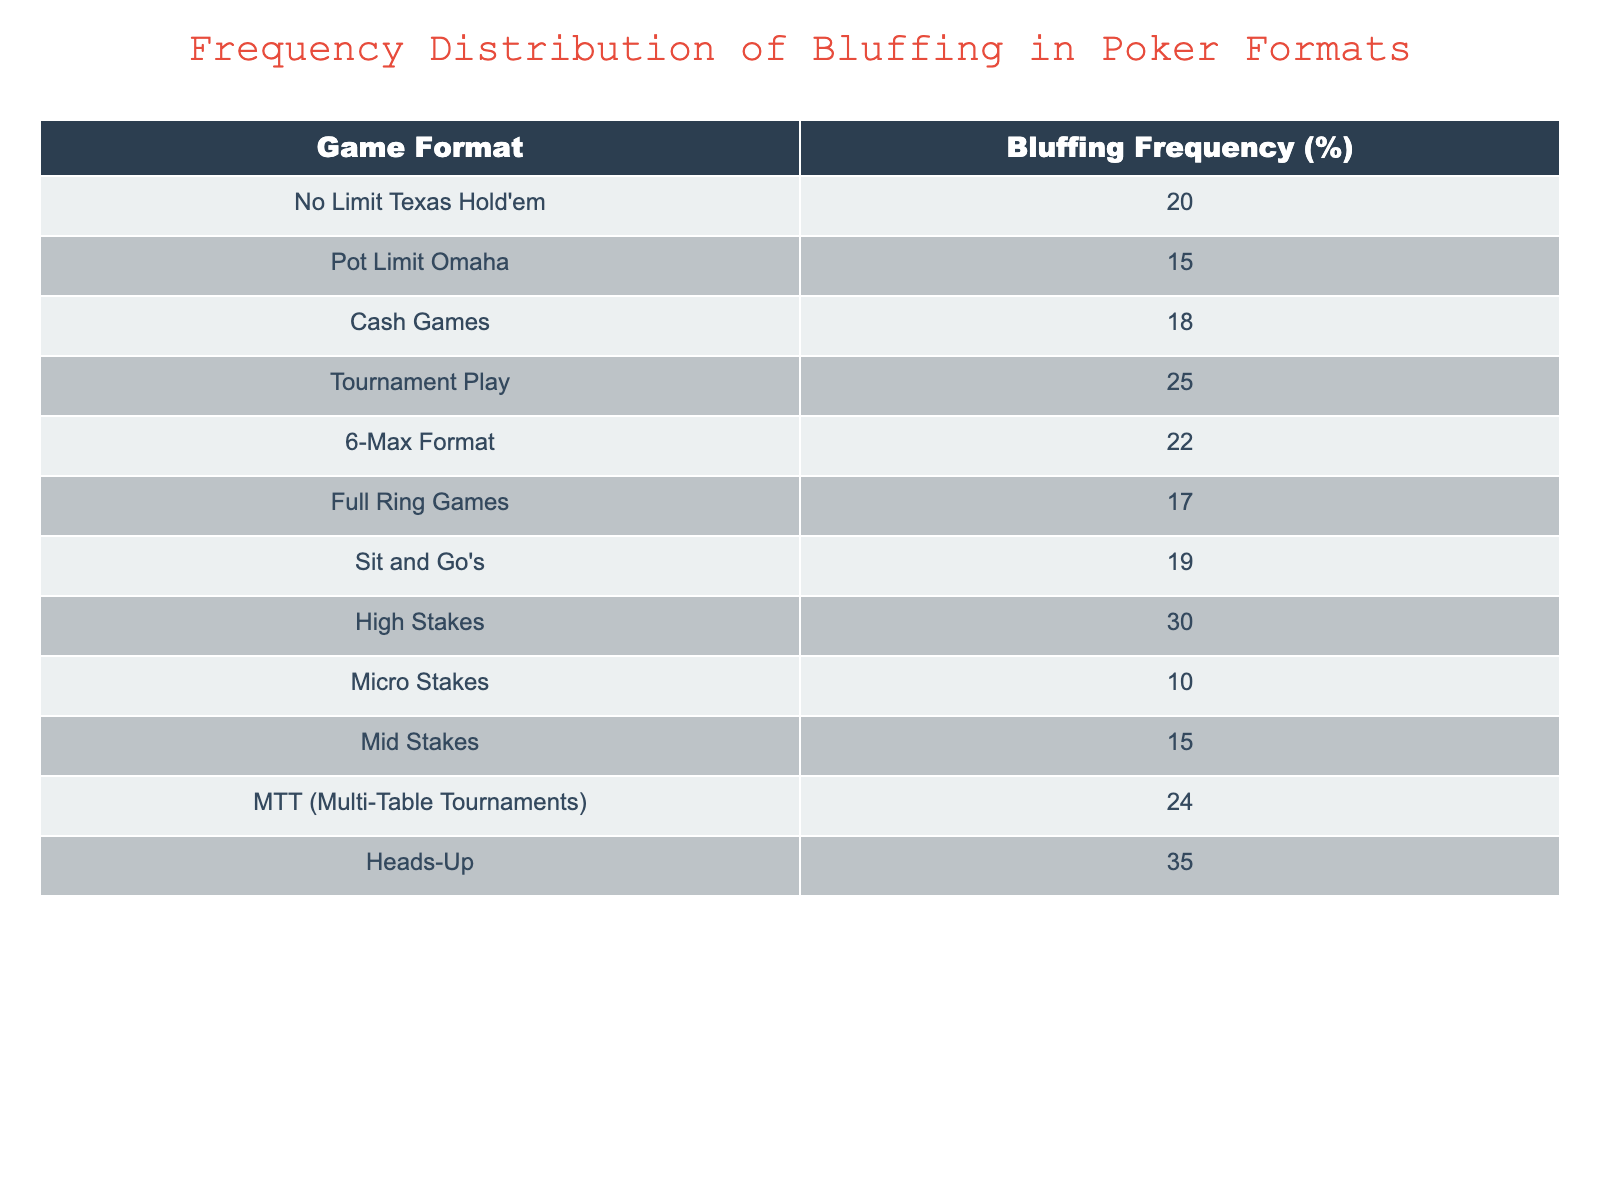What is the bluffing frequency in Heads-Up format? According to the table, the bluffing frequency in Heads-Up format is listed directly, which shows a value of 35%
Answer: 35% What is the bluffing frequency for Micro Stakes? The table indicates that the bluffing frequency for Micro Stakes is specifically shown as 10%
Answer: 10% Which format has the highest bluffing frequency? By examining the table, Heads-Up format has the highest bluffing frequency of 35%, which is greater than all other formats listed
Answer: Heads-Up What is the average bluffing frequency for all game formats listed? To find the average, sum all the bluffing frequencies (20 + 15 + 18 + 25 + 22 + 17 + 19 + 30 + 10 + 15 + 24 + 35 =  24) and then divide by the number of formats (12). So the average is 24/12 = 20%
Answer: 20% Is it true that the bluffing frequency in Tournament Play is greater than in Full Ring Games? By comparing the specific values in the table, Tournament Play has a bluffing frequency of 25%, while Full Ring Games has 17%. Since 25% is greater than 17%, the statement is true
Answer: Yes What is the difference in bluffing frequency between High Stakes and Cash Games? The bluffing frequency in High Stakes is 30%, and in Cash Games, it is 18%. The difference is calculated by subtracting: 30 - 18 = 12%. Thus, there is a 12% difference in favor of High Stakes
Answer: 12% Which has a lower bluffing frequency: Sit and Go's or Mid Stakes? The table shows Sit and Go's at 19% and Mid Stakes at 15%. Since 19% is greater than 15%, Mid Stakes has a lower frequency
Answer: Mid Stakes What is the combined bluffing frequency of Pot Limit Omaha and 6-Max Format? Looking at the table, Pot Limit Omaha has a frequency of 15%, and 6-Max Format has 22%. Adding these together gives: 15 + 22 = 37%. Therefore, the combined frequency is 37%
Answer: 37% 